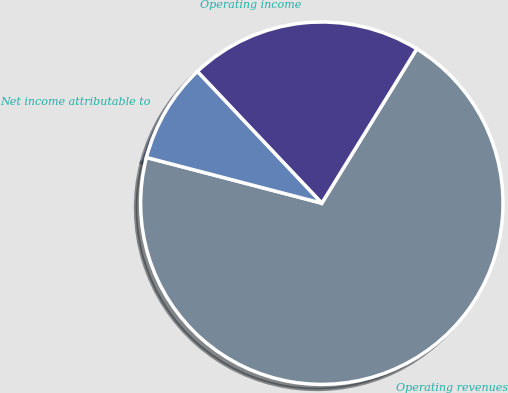Convert chart to OTSL. <chart><loc_0><loc_0><loc_500><loc_500><pie_chart><fcel>Operating revenues<fcel>Operating income<fcel>Net income attributable to<nl><fcel>70.29%<fcel>20.83%<fcel>8.89%<nl></chart> 